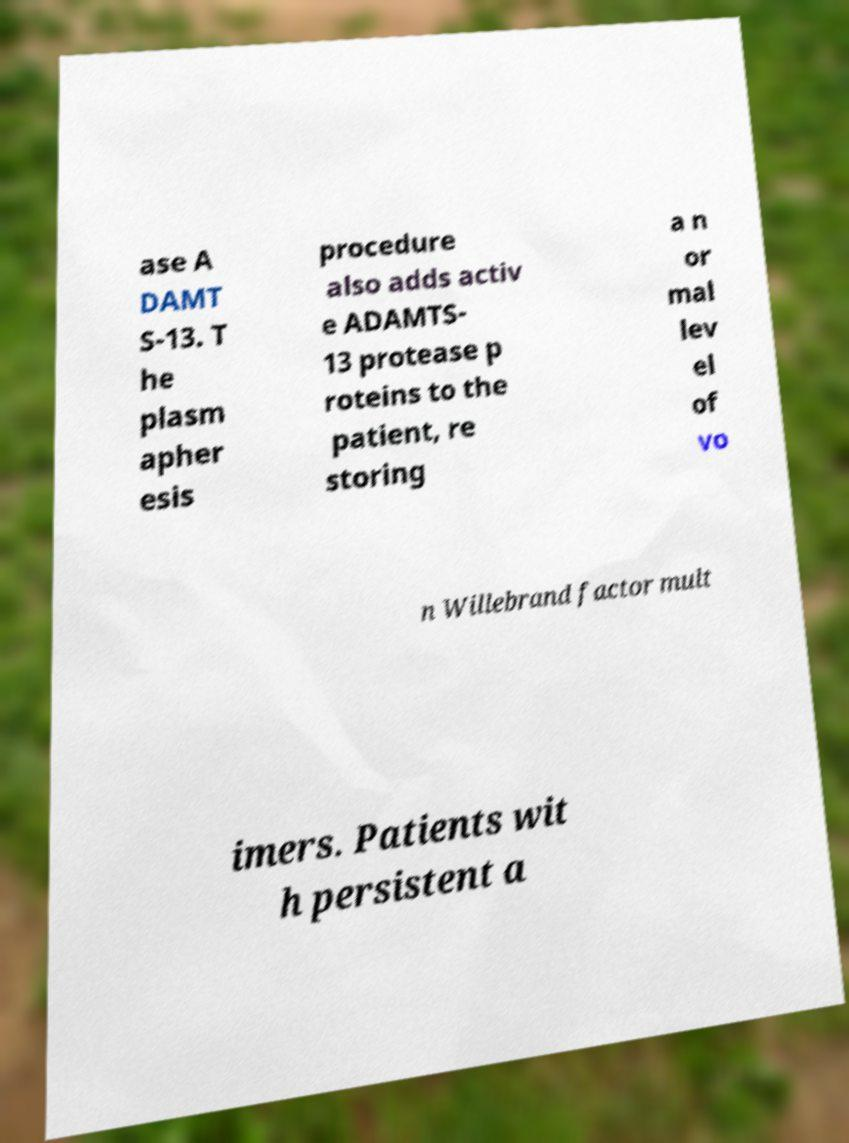Please identify and transcribe the text found in this image. ase A DAMT S-13. T he plasm apher esis procedure also adds activ e ADAMTS- 13 protease p roteins to the patient, re storing a n or mal lev el of vo n Willebrand factor mult imers. Patients wit h persistent a 